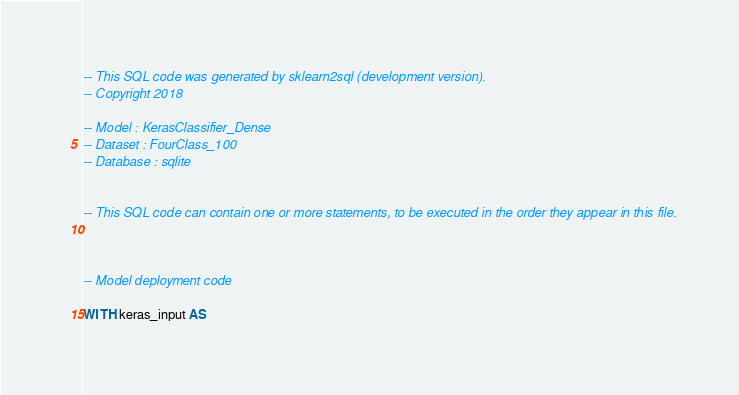Convert code to text. <code><loc_0><loc_0><loc_500><loc_500><_SQL_>-- This SQL code was generated by sklearn2sql (development version).
-- Copyright 2018

-- Model : KerasClassifier_Dense
-- Dataset : FourClass_100
-- Database : sqlite


-- This SQL code can contain one or more statements, to be executed in the order they appear in this file.



-- Model deployment code

WITH keras_input AS </code> 